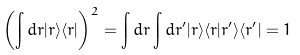Convert formula to latex. <formula><loc_0><loc_0><loc_500><loc_500>\left ( \int d { r } | { r } \rangle \langle { r } | \right ) ^ { 2 } = \int d { r } \int d { r } ^ { \prime } | { r } \rangle \langle { r } | { r } ^ { \prime } \rangle \langle { r } ^ { \prime } | = 1</formula> 